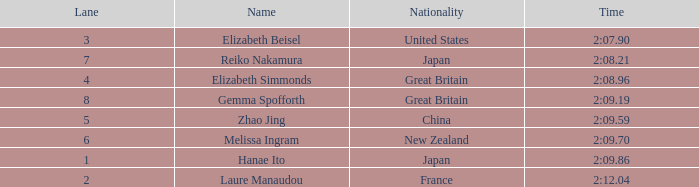What is Elizabeth Simmonds' average lane number? 4.0. 